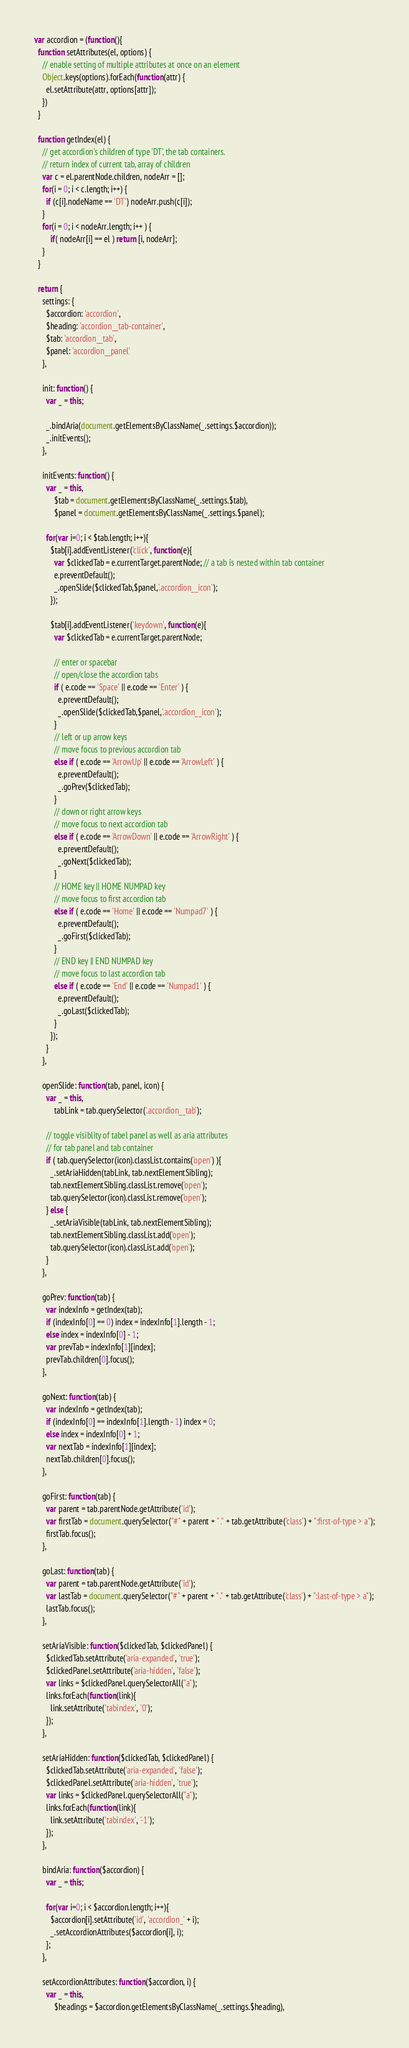Convert code to text. <code><loc_0><loc_0><loc_500><loc_500><_JavaScript_>var accordion = (function(){
  function setAttributes(el, options) {
    // enable setting of multiple attributes at once on an element
    Object.keys(options).forEach(function(attr) {
      el.setAttribute(attr, options[attr]);
    })
  }

  function getIndex(el) {
    // get accordion's children of type 'DT', the tab containers.
    // return index of current tab, array of children
    var c = el.parentNode.children, nodeArr = [];
    for(i = 0; i < c.length; i++) {
      if (c[i].nodeName == 'DT') nodeArr.push(c[i]);
    }
    for(i = 0; i < nodeArr.length; i++ ) {
        if( nodeArr[i] == el ) return [i, nodeArr];
    }
  }

  return {
    settings: {
      $accordion: 'accordion',
      $heading: 'accordion__tab-container',
      $tab: 'accordion__tab',
      $panel: 'accordion__panel'
    },

    init: function() {
      var _ = this;

      _.bindAria(document.getElementsByClassName(_.settings.$accordion));
      _.initEvents();
    },

    initEvents: function() {
      var _ = this,
          $tab = document.getElementsByClassName(_.settings.$tab),
          $panel = document.getElementsByClassName(_.settings.$panel);

      for(var i=0; i < $tab.length; i++){
        $tab[i].addEventListener('click', function(e){
          var $clickedTab = e.currentTarget.parentNode; // a tab is nested within tab container
          e.preventDefault();
          _.openSlide($clickedTab,$panel,'.accordion__icon');
        });

        $tab[i].addEventListener('keydown', function(e){
          var $clickedTab = e.currentTarget.parentNode;

          // enter or spacebar
          // open/close the accordion tabs
          if ( e.code == 'Space' || e.code == 'Enter' ) {
            e.preventDefault();
            _.openSlide($clickedTab,$panel,'.accordion__icon');
          } 
          // left or up arrow keys
          // move focus to previous accordion tab
          else if ( e.code == 'ArrowUp' || e.code == 'ArrowLeft' ) {
            e.preventDefault();
            _.goPrev($clickedTab);
          }
          // down or right arrow keys
          // move focus to next accordion tab
          else if ( e.code == 'ArrowDown' || e.code == 'ArrowRight' ) {
            e.preventDefault();
            _.goNext($clickedTab);
          }
          // HOME key || HOME NUMPAD key
          // move focus to first accordion tab
          else if ( e.code == 'Home' || e.code == 'Numpad7' ) {
            e.preventDefault();
            _.goFirst($clickedTab);
          }
          // END key || END NUMPAD key
          // move focus to last accordion tab
          else if ( e.code == 'End' || e.code == 'Numpad1' ) {
            e.preventDefault();
            _.goLast($clickedTab);
          }
        });   
      }
    },

    openSlide: function(tab, panel, icon) {
      var _ = this,
          tabLink = tab.querySelector('.accordion__tab');

      // toggle visiblity of tabel panel as well as aria attributes
      // for tab panel and tab container
      if ( tab.querySelector(icon).classList.contains('open') ){
        _.setAriaHidden(tabLink, tab.nextElementSibling);
        tab.nextElementSibling.classList.remove('open');
        tab.querySelector(icon).classList.remove('open');
      } else {
        _.setAriaVisible(tabLink, tab.nextElementSibling);
        tab.nextElementSibling.classList.add('open');
        tab.querySelector(icon).classList.add('open');
      }
    },

    goPrev: function(tab) {
      var indexInfo = getIndex(tab);
      if (indexInfo[0] == 0) index = indexInfo[1].length - 1;
      else index = indexInfo[0] - 1;
      var prevTab = indexInfo[1][index];
      prevTab.children[0].focus();
    },

    goNext: function(tab) {
      var indexInfo = getIndex(tab);
      if (indexInfo[0] == indexInfo[1].length - 1) index = 0;
      else index = indexInfo[0] + 1;
      var nextTab = indexInfo[1][index];
      nextTab.children[0].focus();
    },

    goFirst: function(tab) {
      var parent = tab.parentNode.getAttribute('id');
      var firstTab = document.querySelector("#" + parent + " ." + tab.getAttribute('class') + ":first-of-type > a");
      firstTab.focus();
    },

    goLast: function(tab) {
      var parent = tab.parentNode.getAttribute('id');
      var lastTab = document.querySelector("#" + parent + " ." + tab.getAttribute('class') + ":last-of-type > a");
      lastTab.focus();
    },

    setAriaVisible: function($clickedTab, $clickedPanel) {
      $clickedTab.setAttribute('aria-expanded', 'true');
      $clickedPanel.setAttribute('aria-hidden', 'false');
      var links = $clickedPanel.querySelectorAll("a");
      links.forEach(function(link){
        link.setAttribute('tabindex', '0');
      });
    },

    setAriaHidden: function($clickedTab, $clickedPanel) {
      $clickedTab.setAttribute('aria-expanded', 'false');
      $clickedPanel.setAttribute('aria-hidden', 'true');
      var links = $clickedPanel.querySelectorAll("a");
      links.forEach(function(link){
        link.setAttribute('tabindex', '-1');
      });
    },

    bindAria: function($accordion) {
      var _ = this;

      for(var i=0; i < $accordion.length; i++){
        $accordion[i].setAttribute('id', 'accordion_' + i);
        _.setAccordionAttributes($accordion[i], i);
      };
    },

    setAccordionAttributes: function($accordion, i) {
      var _ = this,
          $headings = $accordion.getElementsByClassName(_.settings.$heading),</code> 